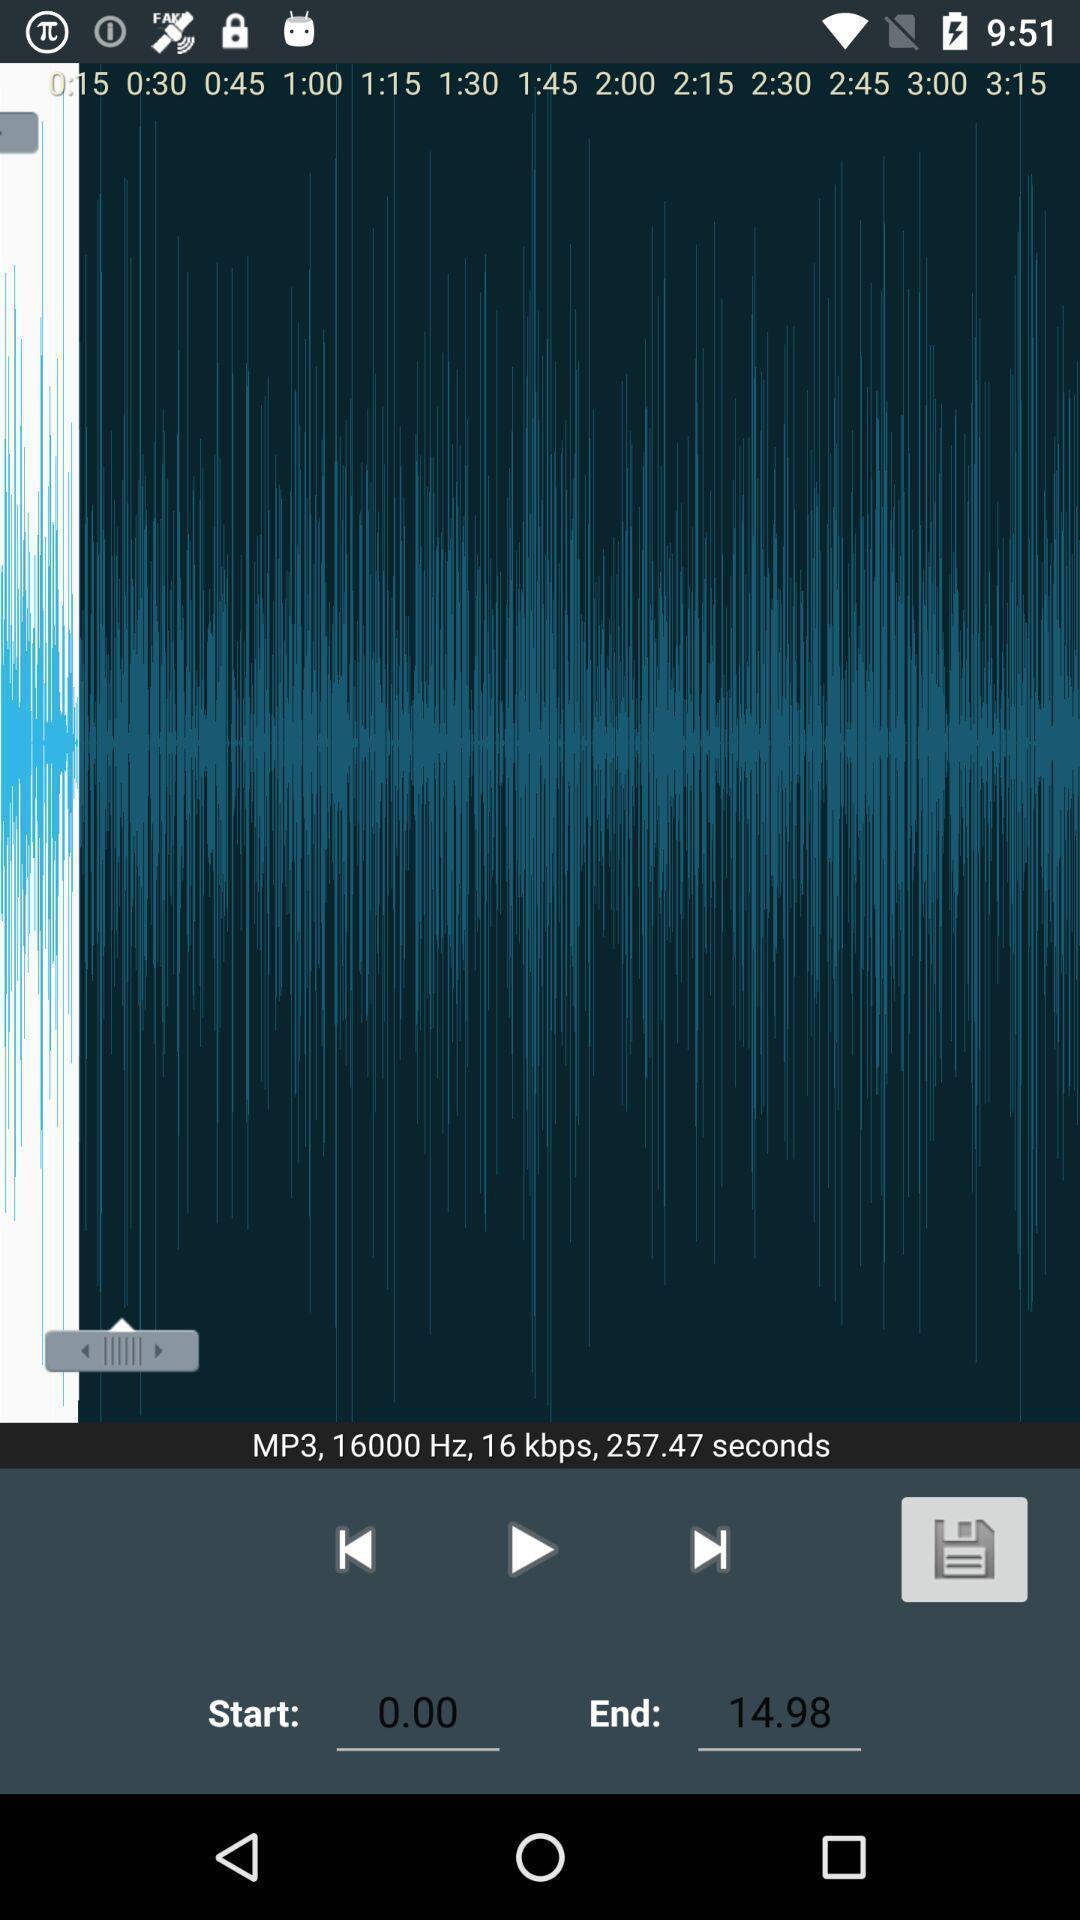Give me a narrative description of this picture. Page displays previous play and next options. 